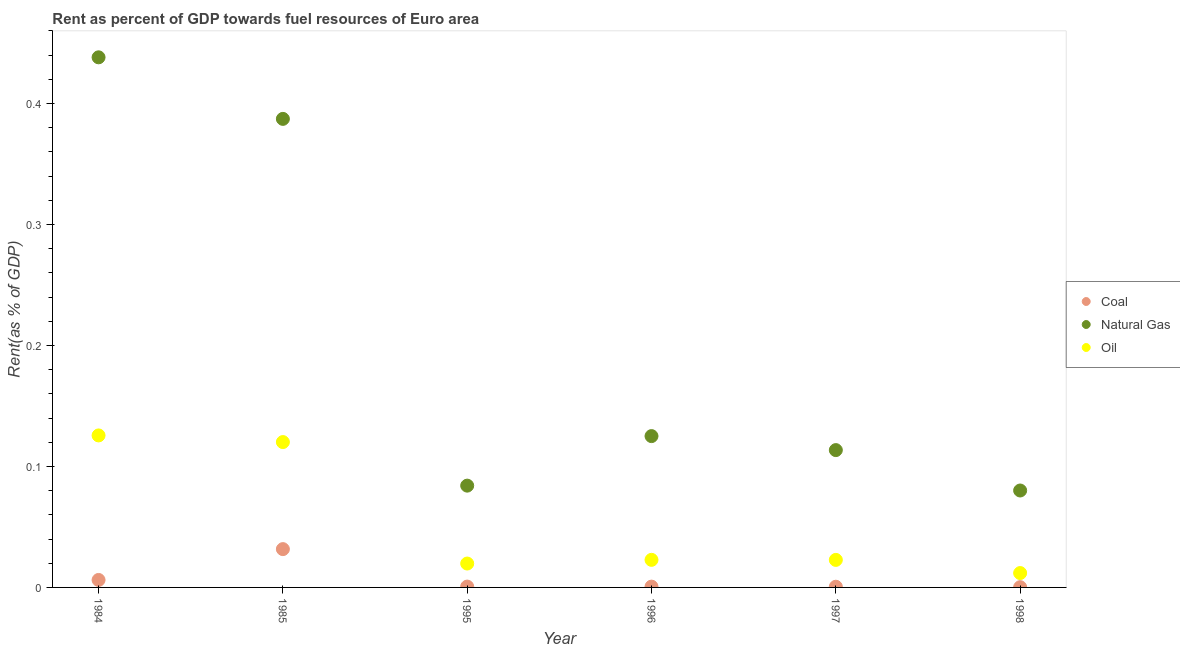How many different coloured dotlines are there?
Make the answer very short. 3. Is the number of dotlines equal to the number of legend labels?
Give a very brief answer. Yes. What is the rent towards oil in 1995?
Your answer should be compact. 0.02. Across all years, what is the maximum rent towards oil?
Keep it short and to the point. 0.13. Across all years, what is the minimum rent towards natural gas?
Your answer should be compact. 0.08. What is the total rent towards natural gas in the graph?
Give a very brief answer. 1.23. What is the difference between the rent towards oil in 1995 and that in 1998?
Give a very brief answer. 0.01. What is the difference between the rent towards natural gas in 1998 and the rent towards oil in 1995?
Ensure brevity in your answer.  0.06. What is the average rent towards oil per year?
Offer a terse response. 0.05. In the year 1995, what is the difference between the rent towards natural gas and rent towards oil?
Your response must be concise. 0.06. In how many years, is the rent towards oil greater than 0.44 %?
Provide a succinct answer. 0. What is the ratio of the rent towards natural gas in 1984 to that in 1995?
Your response must be concise. 5.21. Is the rent towards natural gas in 1984 less than that in 1995?
Make the answer very short. No. Is the difference between the rent towards natural gas in 1985 and 1998 greater than the difference between the rent towards coal in 1985 and 1998?
Provide a short and direct response. Yes. What is the difference between the highest and the second highest rent towards oil?
Provide a short and direct response. 0.01. What is the difference between the highest and the lowest rent towards coal?
Give a very brief answer. 0.03. Is the sum of the rent towards coal in 1985 and 1997 greater than the maximum rent towards natural gas across all years?
Your response must be concise. No. What is the difference between two consecutive major ticks on the Y-axis?
Ensure brevity in your answer.  0.1. Where does the legend appear in the graph?
Ensure brevity in your answer.  Center right. What is the title of the graph?
Your answer should be very brief. Rent as percent of GDP towards fuel resources of Euro area. What is the label or title of the Y-axis?
Offer a terse response. Rent(as % of GDP). What is the Rent(as % of GDP) in Coal in 1984?
Provide a short and direct response. 0.01. What is the Rent(as % of GDP) of Natural Gas in 1984?
Keep it short and to the point. 0.44. What is the Rent(as % of GDP) of Oil in 1984?
Provide a succinct answer. 0.13. What is the Rent(as % of GDP) of Coal in 1985?
Ensure brevity in your answer.  0.03. What is the Rent(as % of GDP) in Natural Gas in 1985?
Your answer should be compact. 0.39. What is the Rent(as % of GDP) of Oil in 1985?
Keep it short and to the point. 0.12. What is the Rent(as % of GDP) in Coal in 1995?
Ensure brevity in your answer.  0. What is the Rent(as % of GDP) of Natural Gas in 1995?
Offer a very short reply. 0.08. What is the Rent(as % of GDP) of Oil in 1995?
Offer a very short reply. 0.02. What is the Rent(as % of GDP) in Coal in 1996?
Ensure brevity in your answer.  0. What is the Rent(as % of GDP) in Natural Gas in 1996?
Provide a short and direct response. 0.13. What is the Rent(as % of GDP) of Oil in 1996?
Make the answer very short. 0.02. What is the Rent(as % of GDP) of Coal in 1997?
Provide a short and direct response. 0. What is the Rent(as % of GDP) in Natural Gas in 1997?
Offer a very short reply. 0.11. What is the Rent(as % of GDP) in Oil in 1997?
Give a very brief answer. 0.02. What is the Rent(as % of GDP) in Coal in 1998?
Your answer should be very brief. 0. What is the Rent(as % of GDP) in Natural Gas in 1998?
Offer a very short reply. 0.08. What is the Rent(as % of GDP) of Oil in 1998?
Your answer should be very brief. 0.01. Across all years, what is the maximum Rent(as % of GDP) in Coal?
Your response must be concise. 0.03. Across all years, what is the maximum Rent(as % of GDP) of Natural Gas?
Offer a very short reply. 0.44. Across all years, what is the maximum Rent(as % of GDP) in Oil?
Your answer should be compact. 0.13. Across all years, what is the minimum Rent(as % of GDP) of Coal?
Offer a very short reply. 0. Across all years, what is the minimum Rent(as % of GDP) of Natural Gas?
Your answer should be very brief. 0.08. Across all years, what is the minimum Rent(as % of GDP) in Oil?
Your response must be concise. 0.01. What is the total Rent(as % of GDP) of Coal in the graph?
Provide a succinct answer. 0.04. What is the total Rent(as % of GDP) in Natural Gas in the graph?
Provide a short and direct response. 1.23. What is the total Rent(as % of GDP) of Oil in the graph?
Provide a short and direct response. 0.32. What is the difference between the Rent(as % of GDP) of Coal in 1984 and that in 1985?
Your answer should be very brief. -0.03. What is the difference between the Rent(as % of GDP) in Natural Gas in 1984 and that in 1985?
Give a very brief answer. 0.05. What is the difference between the Rent(as % of GDP) of Oil in 1984 and that in 1985?
Your answer should be compact. 0.01. What is the difference between the Rent(as % of GDP) of Coal in 1984 and that in 1995?
Your answer should be compact. 0.01. What is the difference between the Rent(as % of GDP) in Natural Gas in 1984 and that in 1995?
Provide a succinct answer. 0.35. What is the difference between the Rent(as % of GDP) of Oil in 1984 and that in 1995?
Provide a short and direct response. 0.11. What is the difference between the Rent(as % of GDP) in Coal in 1984 and that in 1996?
Keep it short and to the point. 0.01. What is the difference between the Rent(as % of GDP) in Natural Gas in 1984 and that in 1996?
Provide a succinct answer. 0.31. What is the difference between the Rent(as % of GDP) of Oil in 1984 and that in 1996?
Offer a terse response. 0.1. What is the difference between the Rent(as % of GDP) in Coal in 1984 and that in 1997?
Your answer should be very brief. 0.01. What is the difference between the Rent(as % of GDP) of Natural Gas in 1984 and that in 1997?
Offer a terse response. 0.32. What is the difference between the Rent(as % of GDP) of Oil in 1984 and that in 1997?
Offer a terse response. 0.1. What is the difference between the Rent(as % of GDP) in Coal in 1984 and that in 1998?
Give a very brief answer. 0.01. What is the difference between the Rent(as % of GDP) in Natural Gas in 1984 and that in 1998?
Make the answer very short. 0.36. What is the difference between the Rent(as % of GDP) in Oil in 1984 and that in 1998?
Provide a succinct answer. 0.11. What is the difference between the Rent(as % of GDP) in Coal in 1985 and that in 1995?
Provide a succinct answer. 0.03. What is the difference between the Rent(as % of GDP) of Natural Gas in 1985 and that in 1995?
Keep it short and to the point. 0.3. What is the difference between the Rent(as % of GDP) of Oil in 1985 and that in 1995?
Your answer should be very brief. 0.1. What is the difference between the Rent(as % of GDP) in Coal in 1985 and that in 1996?
Your answer should be very brief. 0.03. What is the difference between the Rent(as % of GDP) in Natural Gas in 1985 and that in 1996?
Your answer should be very brief. 0.26. What is the difference between the Rent(as % of GDP) in Oil in 1985 and that in 1996?
Offer a terse response. 0.1. What is the difference between the Rent(as % of GDP) of Coal in 1985 and that in 1997?
Provide a succinct answer. 0.03. What is the difference between the Rent(as % of GDP) in Natural Gas in 1985 and that in 1997?
Your answer should be compact. 0.27. What is the difference between the Rent(as % of GDP) of Oil in 1985 and that in 1997?
Give a very brief answer. 0.1. What is the difference between the Rent(as % of GDP) of Coal in 1985 and that in 1998?
Give a very brief answer. 0.03. What is the difference between the Rent(as % of GDP) in Natural Gas in 1985 and that in 1998?
Offer a very short reply. 0.31. What is the difference between the Rent(as % of GDP) in Oil in 1985 and that in 1998?
Offer a very short reply. 0.11. What is the difference between the Rent(as % of GDP) of Coal in 1995 and that in 1996?
Give a very brief answer. 0. What is the difference between the Rent(as % of GDP) of Natural Gas in 1995 and that in 1996?
Make the answer very short. -0.04. What is the difference between the Rent(as % of GDP) of Oil in 1995 and that in 1996?
Keep it short and to the point. -0. What is the difference between the Rent(as % of GDP) in Natural Gas in 1995 and that in 1997?
Give a very brief answer. -0.03. What is the difference between the Rent(as % of GDP) in Oil in 1995 and that in 1997?
Offer a very short reply. -0. What is the difference between the Rent(as % of GDP) of Coal in 1995 and that in 1998?
Your answer should be very brief. 0. What is the difference between the Rent(as % of GDP) of Natural Gas in 1995 and that in 1998?
Ensure brevity in your answer.  0. What is the difference between the Rent(as % of GDP) of Oil in 1995 and that in 1998?
Make the answer very short. 0.01. What is the difference between the Rent(as % of GDP) in Coal in 1996 and that in 1997?
Make the answer very short. 0. What is the difference between the Rent(as % of GDP) in Natural Gas in 1996 and that in 1997?
Keep it short and to the point. 0.01. What is the difference between the Rent(as % of GDP) of Oil in 1996 and that in 1997?
Offer a very short reply. 0. What is the difference between the Rent(as % of GDP) of Natural Gas in 1996 and that in 1998?
Your answer should be very brief. 0.04. What is the difference between the Rent(as % of GDP) in Oil in 1996 and that in 1998?
Ensure brevity in your answer.  0.01. What is the difference between the Rent(as % of GDP) of Natural Gas in 1997 and that in 1998?
Your answer should be very brief. 0.03. What is the difference between the Rent(as % of GDP) of Oil in 1997 and that in 1998?
Your answer should be compact. 0.01. What is the difference between the Rent(as % of GDP) of Coal in 1984 and the Rent(as % of GDP) of Natural Gas in 1985?
Your answer should be very brief. -0.38. What is the difference between the Rent(as % of GDP) of Coal in 1984 and the Rent(as % of GDP) of Oil in 1985?
Ensure brevity in your answer.  -0.11. What is the difference between the Rent(as % of GDP) in Natural Gas in 1984 and the Rent(as % of GDP) in Oil in 1985?
Ensure brevity in your answer.  0.32. What is the difference between the Rent(as % of GDP) in Coal in 1984 and the Rent(as % of GDP) in Natural Gas in 1995?
Give a very brief answer. -0.08. What is the difference between the Rent(as % of GDP) of Coal in 1984 and the Rent(as % of GDP) of Oil in 1995?
Provide a short and direct response. -0.01. What is the difference between the Rent(as % of GDP) of Natural Gas in 1984 and the Rent(as % of GDP) of Oil in 1995?
Offer a terse response. 0.42. What is the difference between the Rent(as % of GDP) in Coal in 1984 and the Rent(as % of GDP) in Natural Gas in 1996?
Make the answer very short. -0.12. What is the difference between the Rent(as % of GDP) of Coal in 1984 and the Rent(as % of GDP) of Oil in 1996?
Your answer should be compact. -0.02. What is the difference between the Rent(as % of GDP) of Natural Gas in 1984 and the Rent(as % of GDP) of Oil in 1996?
Your answer should be very brief. 0.42. What is the difference between the Rent(as % of GDP) of Coal in 1984 and the Rent(as % of GDP) of Natural Gas in 1997?
Offer a terse response. -0.11. What is the difference between the Rent(as % of GDP) of Coal in 1984 and the Rent(as % of GDP) of Oil in 1997?
Give a very brief answer. -0.02. What is the difference between the Rent(as % of GDP) of Natural Gas in 1984 and the Rent(as % of GDP) of Oil in 1997?
Give a very brief answer. 0.42. What is the difference between the Rent(as % of GDP) in Coal in 1984 and the Rent(as % of GDP) in Natural Gas in 1998?
Your answer should be compact. -0.07. What is the difference between the Rent(as % of GDP) of Coal in 1984 and the Rent(as % of GDP) of Oil in 1998?
Provide a succinct answer. -0.01. What is the difference between the Rent(as % of GDP) of Natural Gas in 1984 and the Rent(as % of GDP) of Oil in 1998?
Keep it short and to the point. 0.43. What is the difference between the Rent(as % of GDP) of Coal in 1985 and the Rent(as % of GDP) of Natural Gas in 1995?
Your answer should be compact. -0.05. What is the difference between the Rent(as % of GDP) of Coal in 1985 and the Rent(as % of GDP) of Oil in 1995?
Offer a terse response. 0.01. What is the difference between the Rent(as % of GDP) in Natural Gas in 1985 and the Rent(as % of GDP) in Oil in 1995?
Your response must be concise. 0.37. What is the difference between the Rent(as % of GDP) of Coal in 1985 and the Rent(as % of GDP) of Natural Gas in 1996?
Give a very brief answer. -0.09. What is the difference between the Rent(as % of GDP) of Coal in 1985 and the Rent(as % of GDP) of Oil in 1996?
Make the answer very short. 0.01. What is the difference between the Rent(as % of GDP) in Natural Gas in 1985 and the Rent(as % of GDP) in Oil in 1996?
Give a very brief answer. 0.36. What is the difference between the Rent(as % of GDP) in Coal in 1985 and the Rent(as % of GDP) in Natural Gas in 1997?
Your answer should be very brief. -0.08. What is the difference between the Rent(as % of GDP) of Coal in 1985 and the Rent(as % of GDP) of Oil in 1997?
Provide a succinct answer. 0.01. What is the difference between the Rent(as % of GDP) in Natural Gas in 1985 and the Rent(as % of GDP) in Oil in 1997?
Make the answer very short. 0.36. What is the difference between the Rent(as % of GDP) in Coal in 1985 and the Rent(as % of GDP) in Natural Gas in 1998?
Make the answer very short. -0.05. What is the difference between the Rent(as % of GDP) of Coal in 1985 and the Rent(as % of GDP) of Oil in 1998?
Keep it short and to the point. 0.02. What is the difference between the Rent(as % of GDP) in Natural Gas in 1985 and the Rent(as % of GDP) in Oil in 1998?
Offer a very short reply. 0.38. What is the difference between the Rent(as % of GDP) of Coal in 1995 and the Rent(as % of GDP) of Natural Gas in 1996?
Offer a very short reply. -0.12. What is the difference between the Rent(as % of GDP) in Coal in 1995 and the Rent(as % of GDP) in Oil in 1996?
Provide a short and direct response. -0.02. What is the difference between the Rent(as % of GDP) of Natural Gas in 1995 and the Rent(as % of GDP) of Oil in 1996?
Your response must be concise. 0.06. What is the difference between the Rent(as % of GDP) of Coal in 1995 and the Rent(as % of GDP) of Natural Gas in 1997?
Keep it short and to the point. -0.11. What is the difference between the Rent(as % of GDP) of Coal in 1995 and the Rent(as % of GDP) of Oil in 1997?
Provide a succinct answer. -0.02. What is the difference between the Rent(as % of GDP) in Natural Gas in 1995 and the Rent(as % of GDP) in Oil in 1997?
Keep it short and to the point. 0.06. What is the difference between the Rent(as % of GDP) in Coal in 1995 and the Rent(as % of GDP) in Natural Gas in 1998?
Provide a succinct answer. -0.08. What is the difference between the Rent(as % of GDP) of Coal in 1995 and the Rent(as % of GDP) of Oil in 1998?
Make the answer very short. -0.01. What is the difference between the Rent(as % of GDP) in Natural Gas in 1995 and the Rent(as % of GDP) in Oil in 1998?
Offer a very short reply. 0.07. What is the difference between the Rent(as % of GDP) in Coal in 1996 and the Rent(as % of GDP) in Natural Gas in 1997?
Your answer should be compact. -0.11. What is the difference between the Rent(as % of GDP) in Coal in 1996 and the Rent(as % of GDP) in Oil in 1997?
Ensure brevity in your answer.  -0.02. What is the difference between the Rent(as % of GDP) in Natural Gas in 1996 and the Rent(as % of GDP) in Oil in 1997?
Your response must be concise. 0.1. What is the difference between the Rent(as % of GDP) in Coal in 1996 and the Rent(as % of GDP) in Natural Gas in 1998?
Offer a very short reply. -0.08. What is the difference between the Rent(as % of GDP) of Coal in 1996 and the Rent(as % of GDP) of Oil in 1998?
Ensure brevity in your answer.  -0.01. What is the difference between the Rent(as % of GDP) in Natural Gas in 1996 and the Rent(as % of GDP) in Oil in 1998?
Make the answer very short. 0.11. What is the difference between the Rent(as % of GDP) in Coal in 1997 and the Rent(as % of GDP) in Natural Gas in 1998?
Your response must be concise. -0.08. What is the difference between the Rent(as % of GDP) in Coal in 1997 and the Rent(as % of GDP) in Oil in 1998?
Your answer should be very brief. -0.01. What is the difference between the Rent(as % of GDP) of Natural Gas in 1997 and the Rent(as % of GDP) of Oil in 1998?
Your answer should be compact. 0.1. What is the average Rent(as % of GDP) of Coal per year?
Offer a very short reply. 0.01. What is the average Rent(as % of GDP) in Natural Gas per year?
Keep it short and to the point. 0.2. What is the average Rent(as % of GDP) of Oil per year?
Provide a succinct answer. 0.05. In the year 1984, what is the difference between the Rent(as % of GDP) in Coal and Rent(as % of GDP) in Natural Gas?
Your answer should be compact. -0.43. In the year 1984, what is the difference between the Rent(as % of GDP) in Coal and Rent(as % of GDP) in Oil?
Give a very brief answer. -0.12. In the year 1984, what is the difference between the Rent(as % of GDP) of Natural Gas and Rent(as % of GDP) of Oil?
Your answer should be very brief. 0.31. In the year 1985, what is the difference between the Rent(as % of GDP) of Coal and Rent(as % of GDP) of Natural Gas?
Provide a short and direct response. -0.36. In the year 1985, what is the difference between the Rent(as % of GDP) in Coal and Rent(as % of GDP) in Oil?
Keep it short and to the point. -0.09. In the year 1985, what is the difference between the Rent(as % of GDP) in Natural Gas and Rent(as % of GDP) in Oil?
Keep it short and to the point. 0.27. In the year 1995, what is the difference between the Rent(as % of GDP) of Coal and Rent(as % of GDP) of Natural Gas?
Ensure brevity in your answer.  -0.08. In the year 1995, what is the difference between the Rent(as % of GDP) of Coal and Rent(as % of GDP) of Oil?
Your answer should be very brief. -0.02. In the year 1995, what is the difference between the Rent(as % of GDP) of Natural Gas and Rent(as % of GDP) of Oil?
Provide a short and direct response. 0.06. In the year 1996, what is the difference between the Rent(as % of GDP) in Coal and Rent(as % of GDP) in Natural Gas?
Ensure brevity in your answer.  -0.12. In the year 1996, what is the difference between the Rent(as % of GDP) of Coal and Rent(as % of GDP) of Oil?
Ensure brevity in your answer.  -0.02. In the year 1996, what is the difference between the Rent(as % of GDP) in Natural Gas and Rent(as % of GDP) in Oil?
Your answer should be compact. 0.1. In the year 1997, what is the difference between the Rent(as % of GDP) of Coal and Rent(as % of GDP) of Natural Gas?
Your answer should be very brief. -0.11. In the year 1997, what is the difference between the Rent(as % of GDP) in Coal and Rent(as % of GDP) in Oil?
Your answer should be very brief. -0.02. In the year 1997, what is the difference between the Rent(as % of GDP) in Natural Gas and Rent(as % of GDP) in Oil?
Ensure brevity in your answer.  0.09. In the year 1998, what is the difference between the Rent(as % of GDP) of Coal and Rent(as % of GDP) of Natural Gas?
Your answer should be very brief. -0.08. In the year 1998, what is the difference between the Rent(as % of GDP) of Coal and Rent(as % of GDP) of Oil?
Ensure brevity in your answer.  -0.01. In the year 1998, what is the difference between the Rent(as % of GDP) in Natural Gas and Rent(as % of GDP) in Oil?
Make the answer very short. 0.07. What is the ratio of the Rent(as % of GDP) in Coal in 1984 to that in 1985?
Make the answer very short. 0.2. What is the ratio of the Rent(as % of GDP) of Natural Gas in 1984 to that in 1985?
Your answer should be very brief. 1.13. What is the ratio of the Rent(as % of GDP) in Oil in 1984 to that in 1985?
Make the answer very short. 1.05. What is the ratio of the Rent(as % of GDP) in Coal in 1984 to that in 1995?
Offer a very short reply. 8.96. What is the ratio of the Rent(as % of GDP) of Natural Gas in 1984 to that in 1995?
Keep it short and to the point. 5.21. What is the ratio of the Rent(as % of GDP) in Oil in 1984 to that in 1995?
Provide a succinct answer. 6.36. What is the ratio of the Rent(as % of GDP) of Coal in 1984 to that in 1996?
Your answer should be compact. 9.45. What is the ratio of the Rent(as % of GDP) of Natural Gas in 1984 to that in 1996?
Offer a terse response. 3.5. What is the ratio of the Rent(as % of GDP) of Oil in 1984 to that in 1996?
Your answer should be compact. 5.51. What is the ratio of the Rent(as % of GDP) in Coal in 1984 to that in 1997?
Offer a terse response. 10.79. What is the ratio of the Rent(as % of GDP) of Natural Gas in 1984 to that in 1997?
Keep it short and to the point. 3.86. What is the ratio of the Rent(as % of GDP) of Oil in 1984 to that in 1997?
Provide a short and direct response. 5.52. What is the ratio of the Rent(as % of GDP) of Coal in 1984 to that in 1998?
Make the answer very short. 29.52. What is the ratio of the Rent(as % of GDP) of Natural Gas in 1984 to that in 1998?
Offer a very short reply. 5.47. What is the ratio of the Rent(as % of GDP) of Oil in 1984 to that in 1998?
Your answer should be compact. 10.58. What is the ratio of the Rent(as % of GDP) in Coal in 1985 to that in 1995?
Give a very brief answer. 45.92. What is the ratio of the Rent(as % of GDP) in Natural Gas in 1985 to that in 1995?
Offer a terse response. 4.6. What is the ratio of the Rent(as % of GDP) of Oil in 1985 to that in 1995?
Make the answer very short. 6.09. What is the ratio of the Rent(as % of GDP) in Coal in 1985 to that in 1996?
Make the answer very short. 48.46. What is the ratio of the Rent(as % of GDP) of Natural Gas in 1985 to that in 1996?
Your answer should be very brief. 3.1. What is the ratio of the Rent(as % of GDP) in Oil in 1985 to that in 1996?
Give a very brief answer. 5.27. What is the ratio of the Rent(as % of GDP) of Coal in 1985 to that in 1997?
Your response must be concise. 55.3. What is the ratio of the Rent(as % of GDP) of Natural Gas in 1985 to that in 1997?
Provide a short and direct response. 3.41. What is the ratio of the Rent(as % of GDP) in Oil in 1985 to that in 1997?
Your answer should be very brief. 5.28. What is the ratio of the Rent(as % of GDP) in Coal in 1985 to that in 1998?
Your answer should be compact. 151.34. What is the ratio of the Rent(as % of GDP) of Natural Gas in 1985 to that in 1998?
Keep it short and to the point. 4.83. What is the ratio of the Rent(as % of GDP) in Oil in 1985 to that in 1998?
Provide a succinct answer. 10.12. What is the ratio of the Rent(as % of GDP) in Coal in 1995 to that in 1996?
Offer a terse response. 1.06. What is the ratio of the Rent(as % of GDP) of Natural Gas in 1995 to that in 1996?
Offer a terse response. 0.67. What is the ratio of the Rent(as % of GDP) of Oil in 1995 to that in 1996?
Make the answer very short. 0.87. What is the ratio of the Rent(as % of GDP) of Coal in 1995 to that in 1997?
Offer a very short reply. 1.2. What is the ratio of the Rent(as % of GDP) of Natural Gas in 1995 to that in 1997?
Provide a short and direct response. 0.74. What is the ratio of the Rent(as % of GDP) in Oil in 1995 to that in 1997?
Ensure brevity in your answer.  0.87. What is the ratio of the Rent(as % of GDP) in Coal in 1995 to that in 1998?
Keep it short and to the point. 3.3. What is the ratio of the Rent(as % of GDP) of Natural Gas in 1995 to that in 1998?
Ensure brevity in your answer.  1.05. What is the ratio of the Rent(as % of GDP) in Oil in 1995 to that in 1998?
Provide a short and direct response. 1.66. What is the ratio of the Rent(as % of GDP) of Coal in 1996 to that in 1997?
Ensure brevity in your answer.  1.14. What is the ratio of the Rent(as % of GDP) in Natural Gas in 1996 to that in 1997?
Your answer should be compact. 1.1. What is the ratio of the Rent(as % of GDP) in Oil in 1996 to that in 1997?
Ensure brevity in your answer.  1. What is the ratio of the Rent(as % of GDP) of Coal in 1996 to that in 1998?
Provide a short and direct response. 3.12. What is the ratio of the Rent(as % of GDP) of Natural Gas in 1996 to that in 1998?
Provide a short and direct response. 1.56. What is the ratio of the Rent(as % of GDP) of Oil in 1996 to that in 1998?
Give a very brief answer. 1.92. What is the ratio of the Rent(as % of GDP) in Coal in 1997 to that in 1998?
Your answer should be very brief. 2.74. What is the ratio of the Rent(as % of GDP) in Natural Gas in 1997 to that in 1998?
Offer a very short reply. 1.42. What is the ratio of the Rent(as % of GDP) of Oil in 1997 to that in 1998?
Make the answer very short. 1.92. What is the difference between the highest and the second highest Rent(as % of GDP) of Coal?
Your answer should be compact. 0.03. What is the difference between the highest and the second highest Rent(as % of GDP) of Natural Gas?
Offer a very short reply. 0.05. What is the difference between the highest and the second highest Rent(as % of GDP) of Oil?
Your response must be concise. 0.01. What is the difference between the highest and the lowest Rent(as % of GDP) in Coal?
Provide a succinct answer. 0.03. What is the difference between the highest and the lowest Rent(as % of GDP) in Natural Gas?
Make the answer very short. 0.36. What is the difference between the highest and the lowest Rent(as % of GDP) in Oil?
Your answer should be compact. 0.11. 